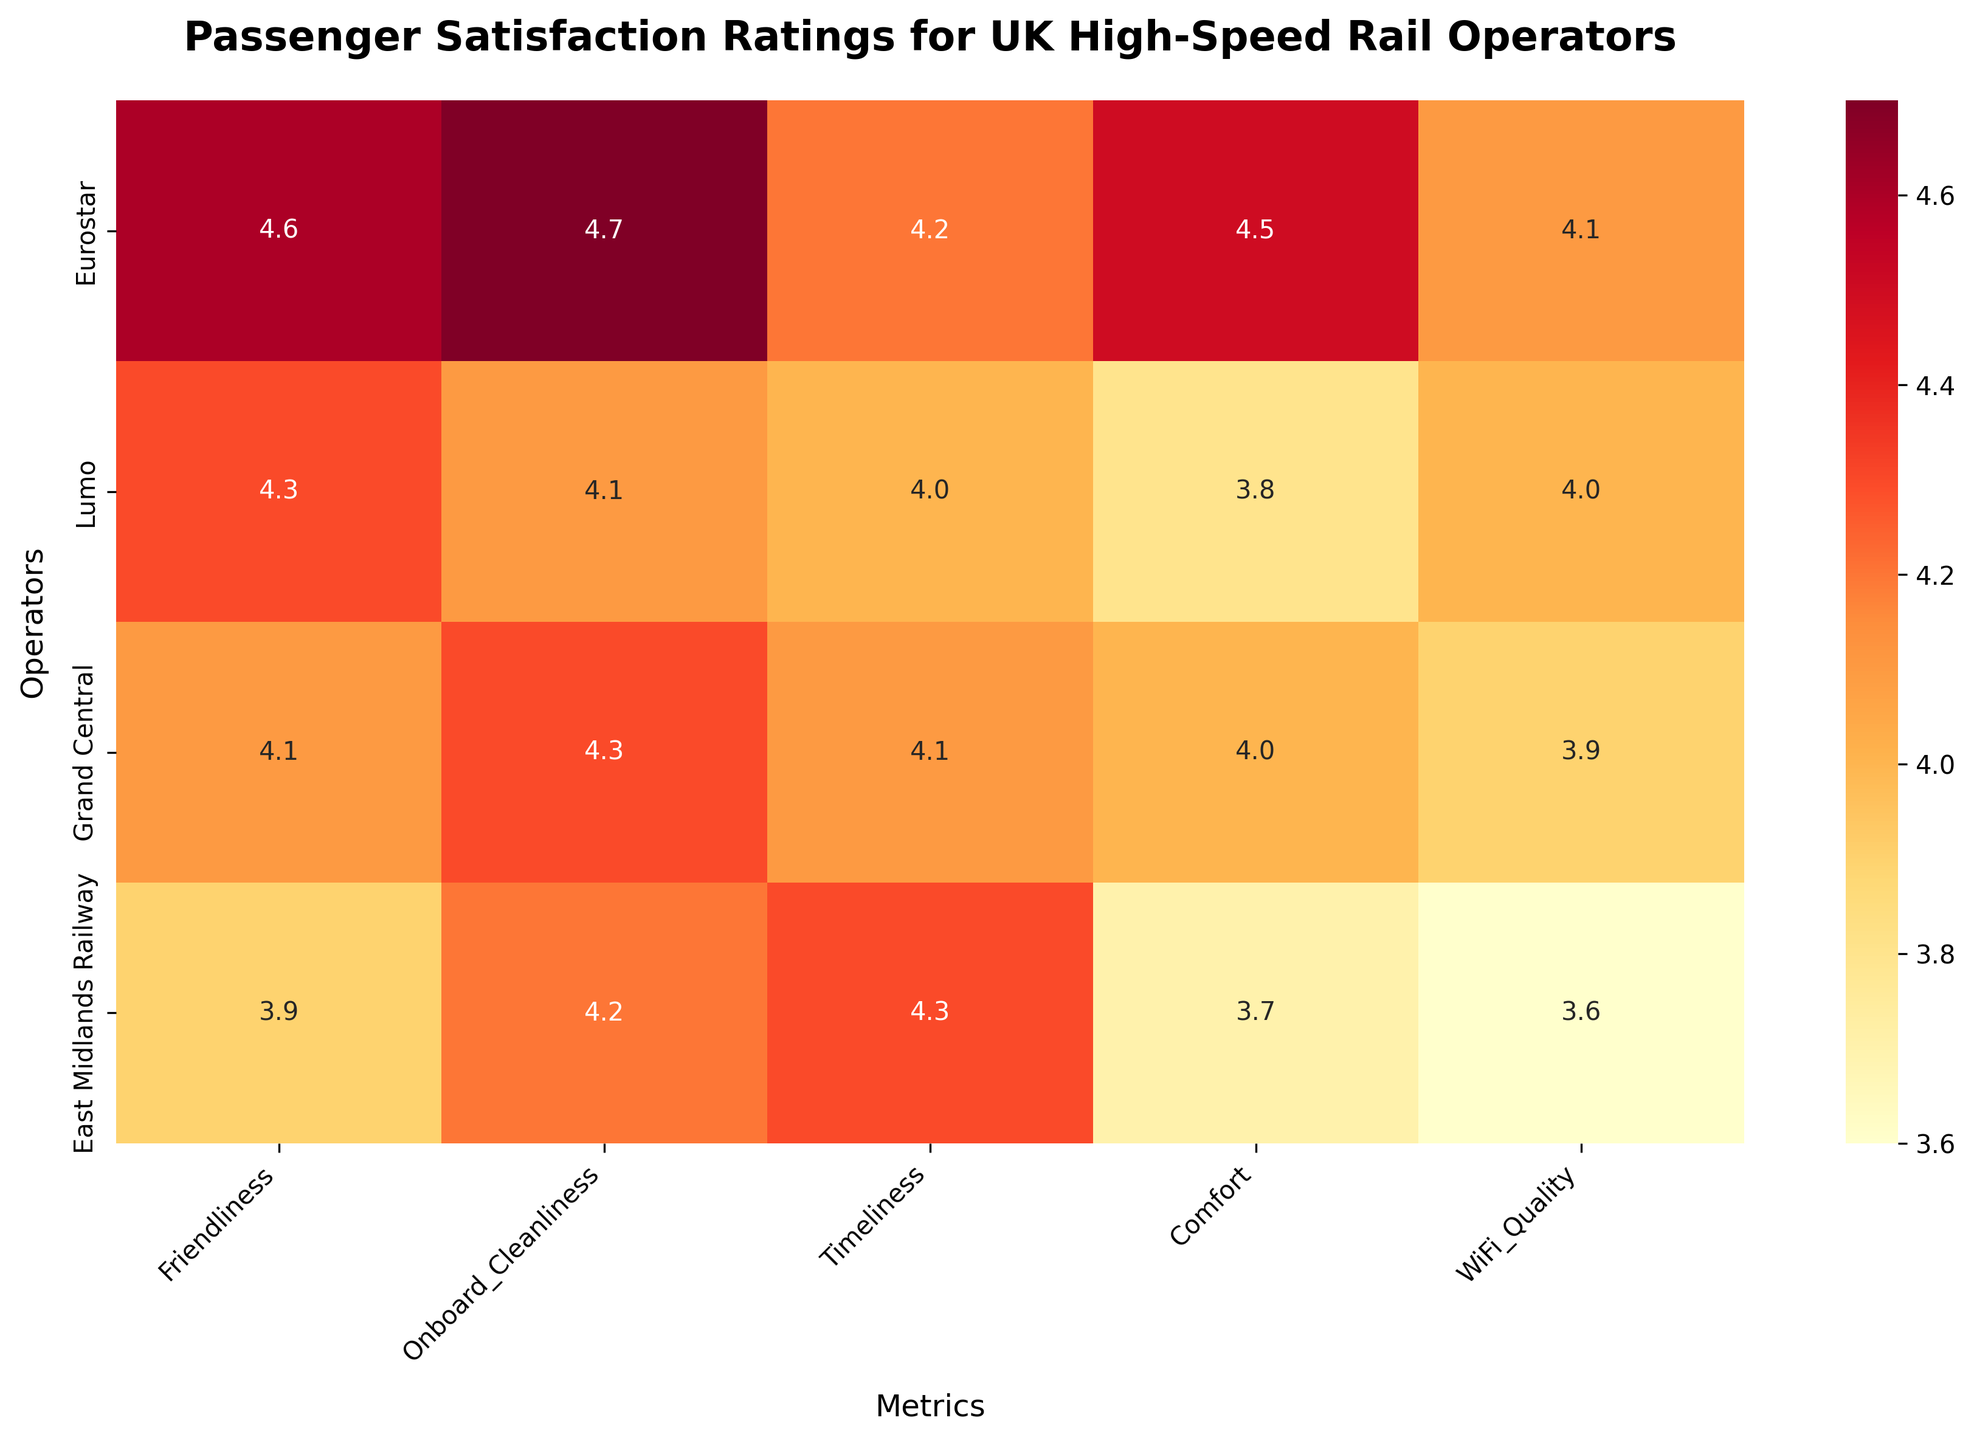What is the highest passenger satisfaction rating across all metrics and operators? By looking at the heatmap, find the highest value among all the ratings displayed and identify the corresponding operator and metric.
Answer: 4.7 What metric received the lowest rating for East Midlands Railway? Locate East Midlands Railway on the y-axis, then identify the lowest value among its corresponding ratings on the x-axis.
Answer: WiFi Quality: 3.6 Which operator received the highest rating for Comfort? Find the Comfort column and identify the highest value in that column, then find the corresponding operator on the y-axis.
Answer: Eurostar: 4.5 How many operators have an average rating of 4.0 or above for Timeliness? For each operator, locate the Timeliness column and check if the value is 4.0 or above, then count the number of such operators.
Answer: Three operators Which operator has a greater difference between Onboard Cleanliness and WiFi Quality ratings: Lumo or Grand Central? Calculate the difference between Onboard Cleanliness and WiFi Quality for both Lumo and Grand Central and compare the results.
Lumo: 4.1 - 4.0 = 0.1
Grand Central: 4.3 - 3.9 = 0.4
Answer: Grand Central Which metric shows the least variability in ratings across all operators? Calculate the range (max - min) for each metric and identify the one with the smallest range.
For Friendliness, the range is: 4.6 - 3.9 = 0.7
For Onboard Cleanliness, the range is: 4.7 - 4.1 = 0.6
For Timeliness, the range is: 4.3 - 4.0 = 0.3
For Comfort, the range is: 4.5 - 3.7 = 0.8
For WiFi Quality, the range is: 4.1 - 3.6 = 0.5
Answer: Timeliness: 0.3 What is the average passenger satisfaction rating for Lumo across all metrics? Add up all satisfaction ratings for Lumo and then divide by the number of metrics.
(4.3 + 4.1 + 4.0 + 3.8 + 4.0) / 5 = 4.04
Answer: 4.04 Which two operators have the closest ratings for Friendliness? Compare the Friendliness ratings for all operators and identify the two with the closest values.
Eurostar: 4.6
Lumo: 4.3
Grand Central: 4.1
East Midlands Railway: 3.9
Answer: Lumo and Grand Central: 0.2 What is the difference between the highest and lowest WiFi Quality ratings among all operators? Identify the highest and lowest WiFi Quality ratings, then calculate the difference.
Highest WiFi Quality: 4.1
Lowest WiFi Quality: 3.6 
Difference: 4.1 - 3.6 = 0.5
Answer: 0.5 